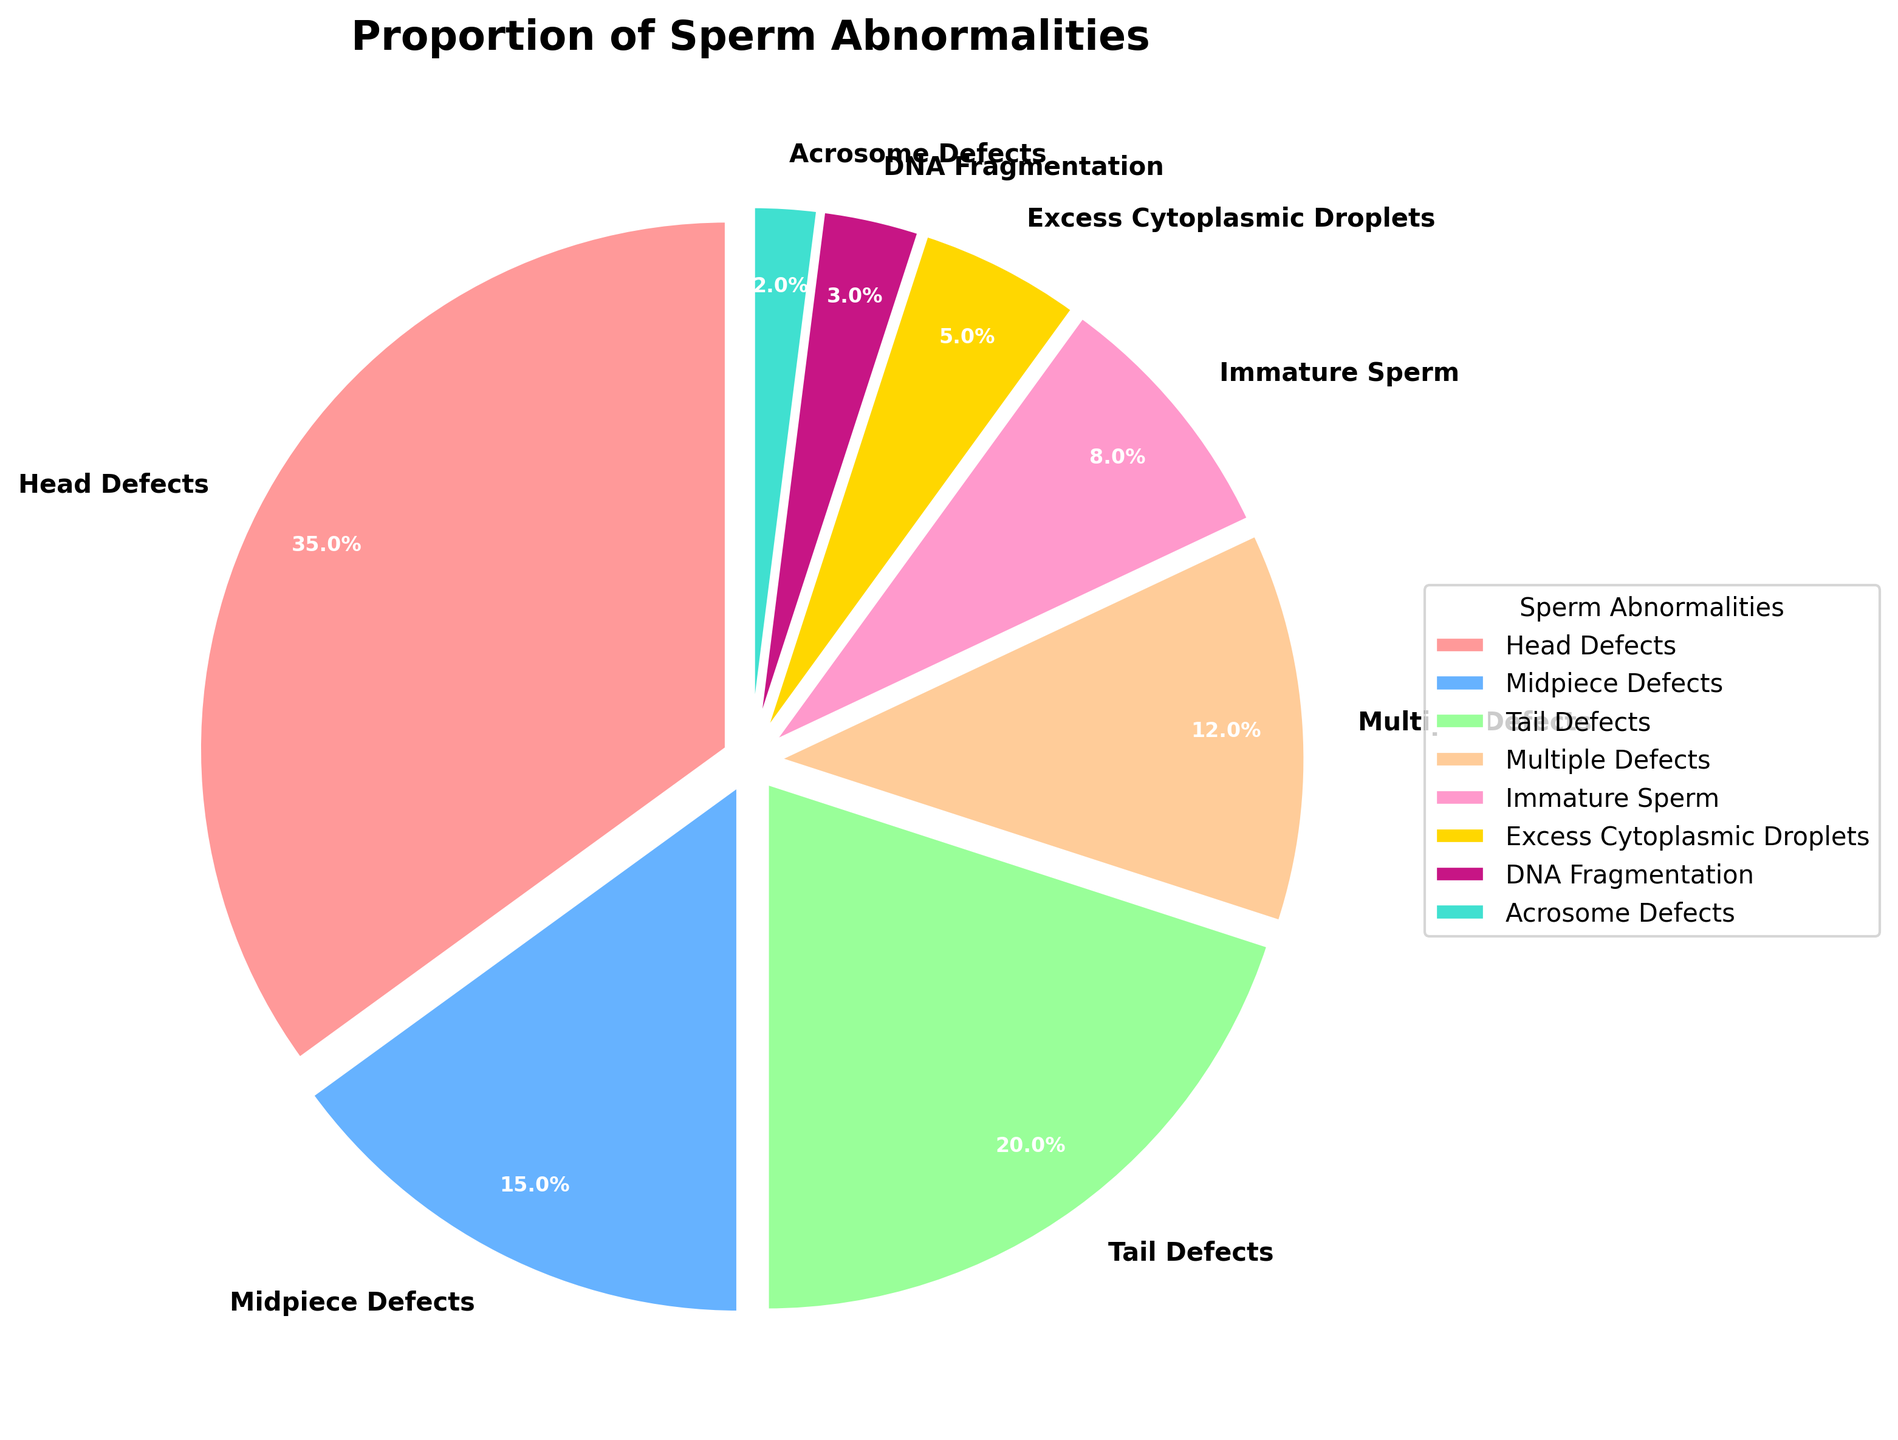What is the most common sperm abnormality shown in the figure? The largest slice of the pie chart represents the most common sperm abnormality. By looking at the size of the wedges, "Head Defects" has the largest slice, occupying 35% of the chart.
Answer: Head Defects What proportion of sperm abnormalities is due to Midpiece Defects compared to Immature Sperm? The percentage of Midpiece Defects (15%) is given directly in the chart, and the percentage of Immature Sperm is 8%. By comparing these values, we see that Midpiece Defects is nearly twice the proportion of Immature Sperm. Specifically, 15% is greater than 8%.
Answer: Midpiece Defects is nearly twice as Immature Sperm What is the total percentage of sperm abnormalities from Tail Defects, DNA Fragmentation, and Acrosome Defects combined? Add the percentages of the three categories: Tail Defects (20%), DNA Fragmentation (3%), and Acrosome Defects (2%). 20% + 3% + 2% = 25%.
Answer: 25% Which sperm abnormality category has the smallest proportion? The smallest slice in the pie chart represents the category with the smallest proportion. This is "Acrosome Defects" with 2%.
Answer: Acrosome Defects How does the percentage of Multiple Defects compare to that of Tail Defects? The percentage of Multiple Defects is 12%, and the percentage of Tail Defects is 20%. Comparing these values, Tail Defects has a higher proportion than Multiple Defects.
Answer: Tail Defects has a higher proportion What percentage of sperm abnormalities is due to Excess Cytoplasmic Droplets and DNA Fragmentation combined? Add the percentages of Excess Cytoplasmic Droplets (5%) and DNA Fragmentation (3%). 5% + 3% = 8%.
Answer: 8% What is the difference in percentage between the most and least common sperm abnormalities? Subtract the percentage of the least common abnormality (Acrosome Defects, 2%) from the most common one (Head Defects, 35%). 35% - 2% = 33%.
Answer: 33% Are there more Head Defects or Tail Defects? To determine this, compare the percentages of Head Defects (35%) and Tail Defects (20%). 35% > 20%, indicating that there are more Head Defects.
Answer: Head Defects Which sperm abnormality categories occupy at least 10% each of the total abnormalities? Identify categories with percentages equal to or greater than 10%: Head Defects (35%), Midpiece Defects (15%), and Tail Defects (20%).
Answer: Head Defects, Midpiece Defects, Tail Defects If you combine the categories with the smallest proportions, what is their total percentage? Combine the percentages for DNA Fragmentation (3%) and Acrosome Defects (2%). 3% + 2% = 5%.
Answer: 5% 